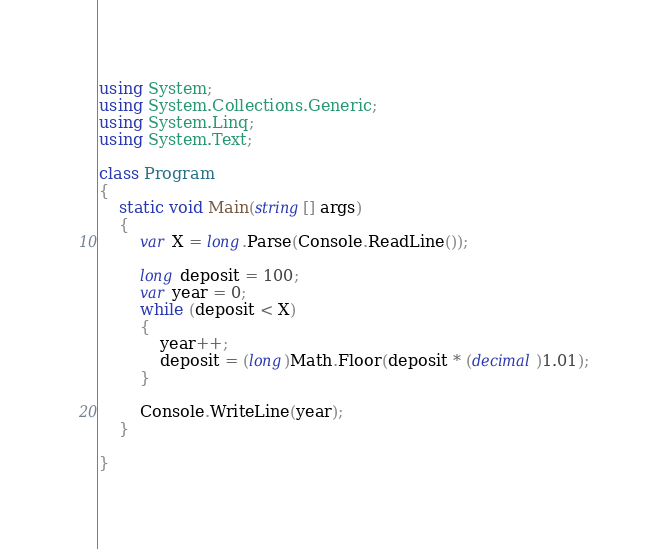Convert code to text. <code><loc_0><loc_0><loc_500><loc_500><_C#_>using System;
using System.Collections.Generic;
using System.Linq;
using System.Text;

class Program
{
    static void Main(string[] args)
    {
        var X = long.Parse(Console.ReadLine());

        long deposit = 100;
        var year = 0;
        while (deposit < X)
        {
            year++;
            deposit = (long)Math.Floor(deposit * (decimal)1.01);
        }

        Console.WriteLine(year);
    }

}
</code> 